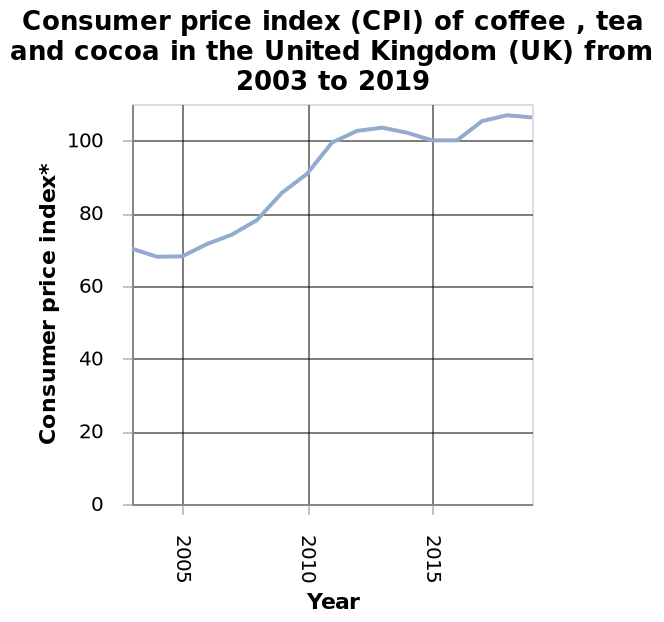<image>
How much did the CPI for coffee, tea, and cocoa increase from 2010 to its peak in the UK? The CPI for coffee, tea, and cocoa increased from 70 to over 100 from 2010 to its peak in the UK. When did the CPI for coffee, tea, and cocoa reach its peak in the UK?  The CPI for coffee, tea, and cocoa reached its peak in the UK in approximately 2012. 